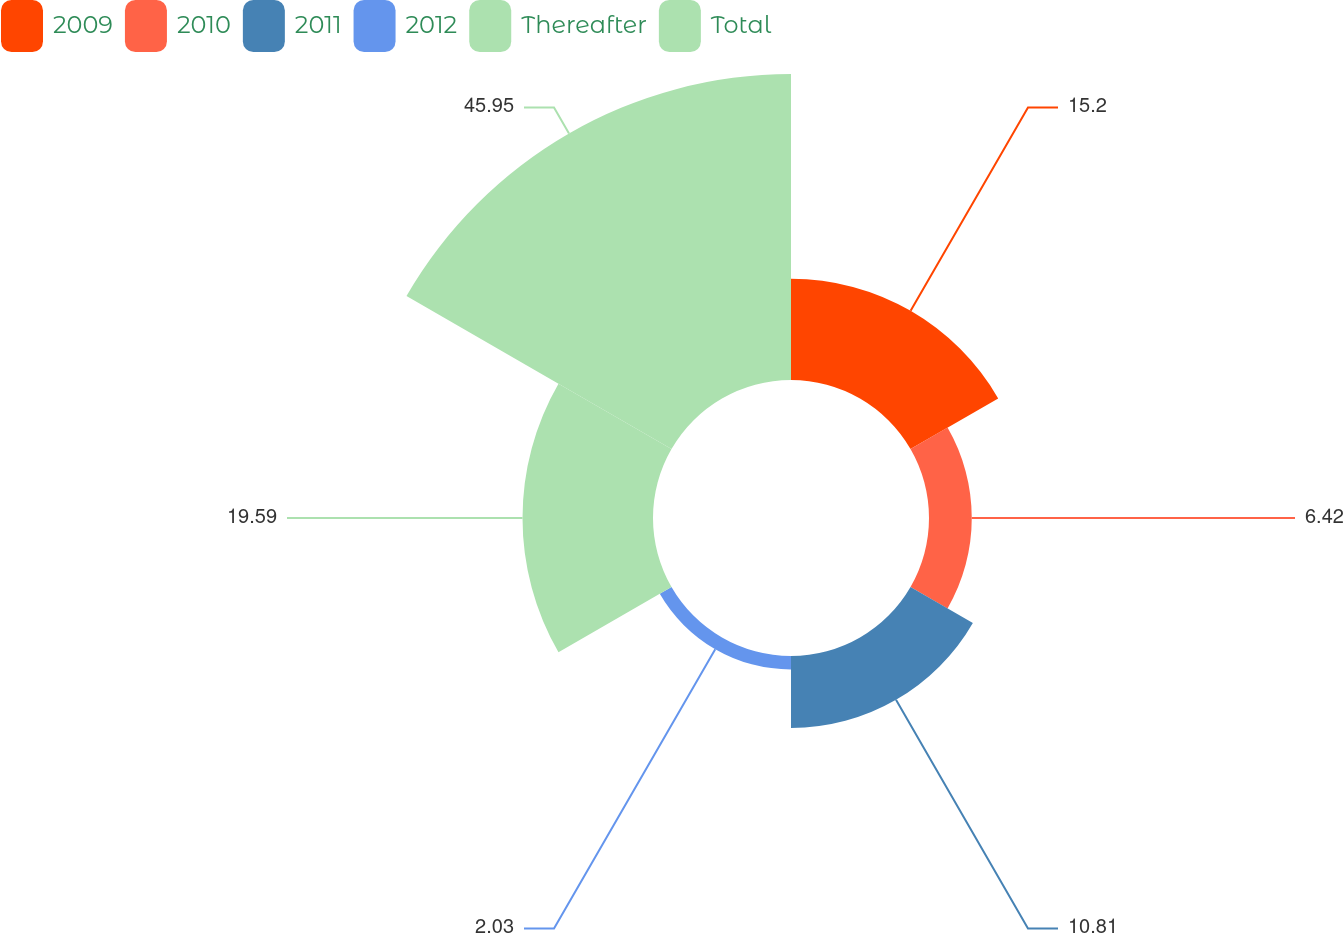<chart> <loc_0><loc_0><loc_500><loc_500><pie_chart><fcel>2009<fcel>2010<fcel>2011<fcel>2012<fcel>Thereafter<fcel>Total<nl><fcel>15.2%<fcel>6.42%<fcel>10.81%<fcel>2.03%<fcel>19.59%<fcel>45.94%<nl></chart> 